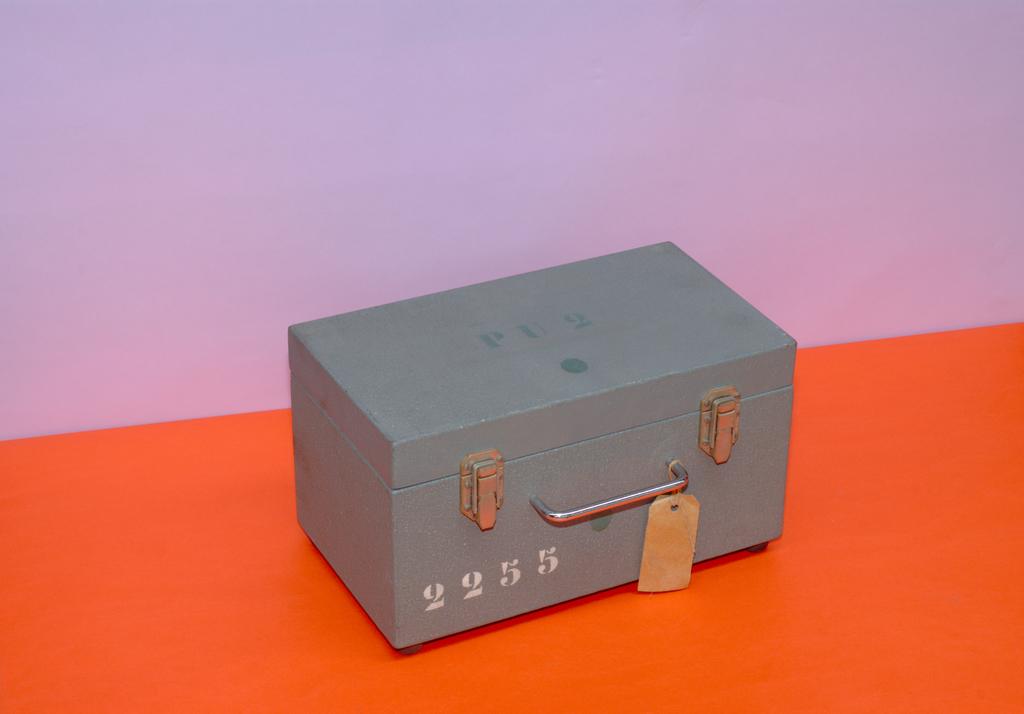What number is on the box?
Your response must be concise. 2255. What is the first number in the sequence shown?
Your answer should be very brief. 2. 